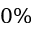<formula> <loc_0><loc_0><loc_500><loc_500>0 \%</formula> 